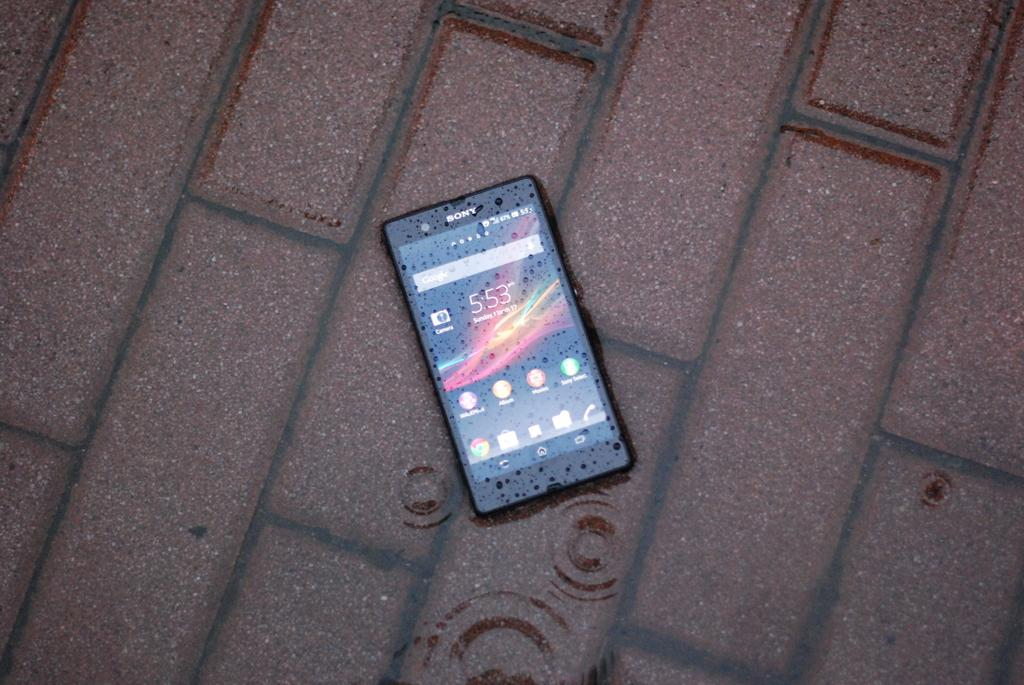<image>
Describe the image concisely. A Sony phone is laying on a brick floor in the rain. 